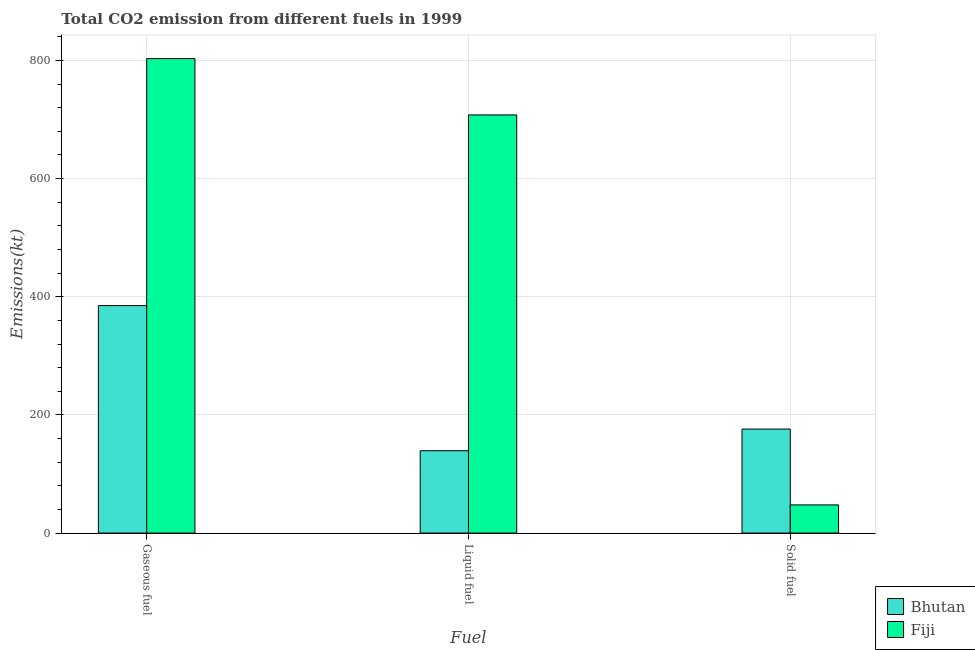Are the number of bars per tick equal to the number of legend labels?
Ensure brevity in your answer.  Yes. How many bars are there on the 2nd tick from the left?
Give a very brief answer. 2. How many bars are there on the 3rd tick from the right?
Your answer should be compact. 2. What is the label of the 3rd group of bars from the left?
Make the answer very short. Solid fuel. What is the amount of co2 emissions from liquid fuel in Fiji?
Your response must be concise. 707.73. Across all countries, what is the maximum amount of co2 emissions from gaseous fuel?
Provide a succinct answer. 803.07. Across all countries, what is the minimum amount of co2 emissions from gaseous fuel?
Your response must be concise. 385.04. In which country was the amount of co2 emissions from solid fuel maximum?
Your answer should be compact. Bhutan. In which country was the amount of co2 emissions from solid fuel minimum?
Your answer should be very brief. Fiji. What is the total amount of co2 emissions from solid fuel in the graph?
Your answer should be compact. 223.69. What is the difference between the amount of co2 emissions from liquid fuel in Bhutan and that in Fiji?
Offer a terse response. -568.39. What is the difference between the amount of co2 emissions from liquid fuel in Fiji and the amount of co2 emissions from gaseous fuel in Bhutan?
Keep it short and to the point. 322.7. What is the average amount of co2 emissions from solid fuel per country?
Provide a short and direct response. 111.84. What is the difference between the amount of co2 emissions from gaseous fuel and amount of co2 emissions from solid fuel in Bhutan?
Provide a short and direct response. 209.02. In how many countries, is the amount of co2 emissions from gaseous fuel greater than 720 kt?
Make the answer very short. 1. What is the ratio of the amount of co2 emissions from gaseous fuel in Fiji to that in Bhutan?
Your answer should be compact. 2.09. Is the amount of co2 emissions from gaseous fuel in Fiji less than that in Bhutan?
Make the answer very short. No. Is the difference between the amount of co2 emissions from gaseous fuel in Fiji and Bhutan greater than the difference between the amount of co2 emissions from liquid fuel in Fiji and Bhutan?
Keep it short and to the point. No. What is the difference between the highest and the second highest amount of co2 emissions from solid fuel?
Offer a terse response. 128.34. What is the difference between the highest and the lowest amount of co2 emissions from gaseous fuel?
Your response must be concise. 418.04. In how many countries, is the amount of co2 emissions from liquid fuel greater than the average amount of co2 emissions from liquid fuel taken over all countries?
Your answer should be compact. 1. What does the 1st bar from the left in Solid fuel represents?
Your answer should be very brief. Bhutan. What does the 1st bar from the right in Solid fuel represents?
Your response must be concise. Fiji. Are all the bars in the graph horizontal?
Provide a short and direct response. No. What is the difference between two consecutive major ticks on the Y-axis?
Provide a short and direct response. 200. Does the graph contain any zero values?
Your response must be concise. No. Does the graph contain grids?
Ensure brevity in your answer.  Yes. Where does the legend appear in the graph?
Your answer should be very brief. Bottom right. How many legend labels are there?
Provide a succinct answer. 2. How are the legend labels stacked?
Offer a very short reply. Vertical. What is the title of the graph?
Offer a very short reply. Total CO2 emission from different fuels in 1999. Does "Grenada" appear as one of the legend labels in the graph?
Offer a very short reply. No. What is the label or title of the X-axis?
Keep it short and to the point. Fuel. What is the label or title of the Y-axis?
Offer a terse response. Emissions(kt). What is the Emissions(kt) of Bhutan in Gaseous fuel?
Your answer should be very brief. 385.04. What is the Emissions(kt) of Fiji in Gaseous fuel?
Your response must be concise. 803.07. What is the Emissions(kt) in Bhutan in Liquid fuel?
Provide a short and direct response. 139.35. What is the Emissions(kt) in Fiji in Liquid fuel?
Provide a succinct answer. 707.73. What is the Emissions(kt) of Bhutan in Solid fuel?
Provide a succinct answer. 176.02. What is the Emissions(kt) of Fiji in Solid fuel?
Keep it short and to the point. 47.67. Across all Fuel, what is the maximum Emissions(kt) of Bhutan?
Keep it short and to the point. 385.04. Across all Fuel, what is the maximum Emissions(kt) of Fiji?
Keep it short and to the point. 803.07. Across all Fuel, what is the minimum Emissions(kt) in Bhutan?
Offer a very short reply. 139.35. Across all Fuel, what is the minimum Emissions(kt) of Fiji?
Your response must be concise. 47.67. What is the total Emissions(kt) of Bhutan in the graph?
Ensure brevity in your answer.  700.4. What is the total Emissions(kt) in Fiji in the graph?
Provide a short and direct response. 1558.47. What is the difference between the Emissions(kt) in Bhutan in Gaseous fuel and that in Liquid fuel?
Your answer should be compact. 245.69. What is the difference between the Emissions(kt) in Fiji in Gaseous fuel and that in Liquid fuel?
Your answer should be compact. 95.34. What is the difference between the Emissions(kt) of Bhutan in Gaseous fuel and that in Solid fuel?
Your answer should be compact. 209.02. What is the difference between the Emissions(kt) of Fiji in Gaseous fuel and that in Solid fuel?
Your answer should be very brief. 755.4. What is the difference between the Emissions(kt) of Bhutan in Liquid fuel and that in Solid fuel?
Offer a terse response. -36.67. What is the difference between the Emissions(kt) of Fiji in Liquid fuel and that in Solid fuel?
Offer a terse response. 660.06. What is the difference between the Emissions(kt) in Bhutan in Gaseous fuel and the Emissions(kt) in Fiji in Liquid fuel?
Give a very brief answer. -322.7. What is the difference between the Emissions(kt) of Bhutan in Gaseous fuel and the Emissions(kt) of Fiji in Solid fuel?
Offer a terse response. 337.36. What is the difference between the Emissions(kt) in Bhutan in Liquid fuel and the Emissions(kt) in Fiji in Solid fuel?
Give a very brief answer. 91.67. What is the average Emissions(kt) in Bhutan per Fuel?
Give a very brief answer. 233.47. What is the average Emissions(kt) in Fiji per Fuel?
Ensure brevity in your answer.  519.49. What is the difference between the Emissions(kt) in Bhutan and Emissions(kt) in Fiji in Gaseous fuel?
Offer a very short reply. -418.04. What is the difference between the Emissions(kt) in Bhutan and Emissions(kt) in Fiji in Liquid fuel?
Your answer should be very brief. -568.38. What is the difference between the Emissions(kt) in Bhutan and Emissions(kt) in Fiji in Solid fuel?
Your answer should be compact. 128.34. What is the ratio of the Emissions(kt) in Bhutan in Gaseous fuel to that in Liquid fuel?
Provide a succinct answer. 2.76. What is the ratio of the Emissions(kt) of Fiji in Gaseous fuel to that in Liquid fuel?
Provide a succinct answer. 1.13. What is the ratio of the Emissions(kt) of Bhutan in Gaseous fuel to that in Solid fuel?
Offer a very short reply. 2.19. What is the ratio of the Emissions(kt) in Fiji in Gaseous fuel to that in Solid fuel?
Ensure brevity in your answer.  16.85. What is the ratio of the Emissions(kt) in Bhutan in Liquid fuel to that in Solid fuel?
Make the answer very short. 0.79. What is the ratio of the Emissions(kt) of Fiji in Liquid fuel to that in Solid fuel?
Provide a short and direct response. 14.85. What is the difference between the highest and the second highest Emissions(kt) in Bhutan?
Provide a short and direct response. 209.02. What is the difference between the highest and the second highest Emissions(kt) of Fiji?
Your answer should be very brief. 95.34. What is the difference between the highest and the lowest Emissions(kt) in Bhutan?
Give a very brief answer. 245.69. What is the difference between the highest and the lowest Emissions(kt) of Fiji?
Offer a terse response. 755.4. 